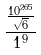<formula> <loc_0><loc_0><loc_500><loc_500>\frac { \frac { 1 0 ^ { 2 6 5 } } { \sqrt { 6 } } } { 1 ^ { 9 } }</formula> 